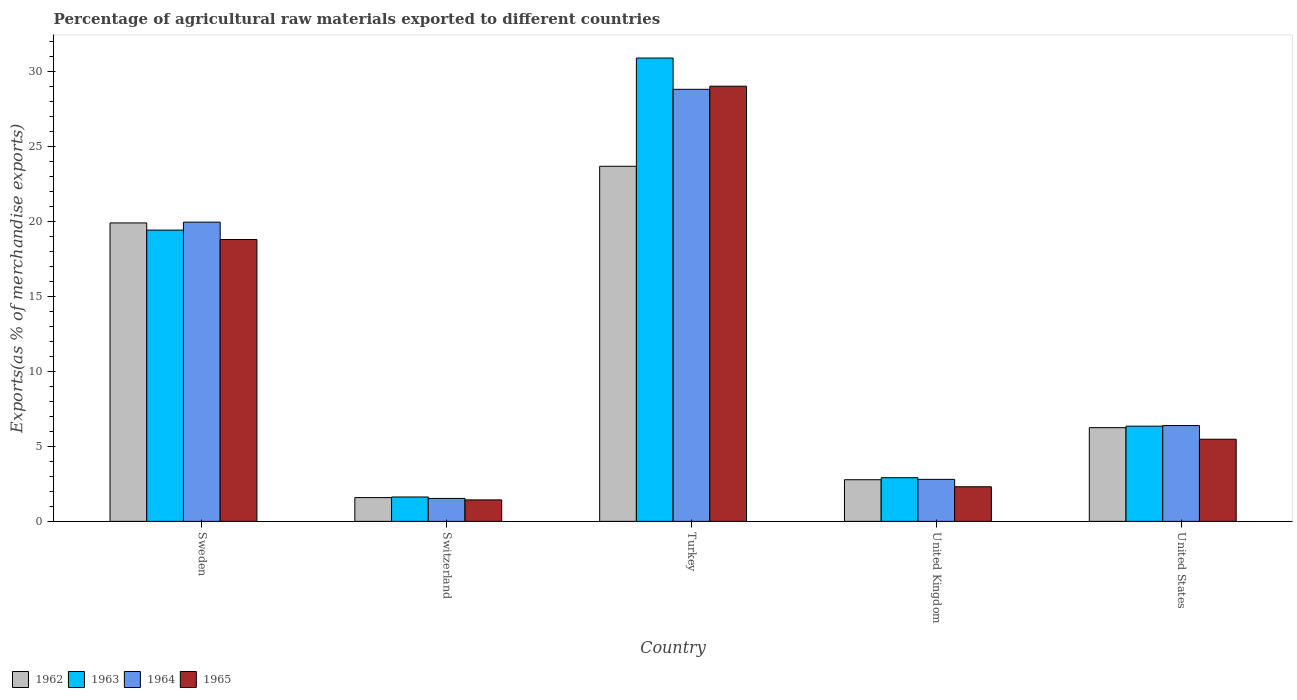How many different coloured bars are there?
Your answer should be very brief. 4. How many bars are there on the 1st tick from the left?
Your answer should be very brief. 4. How many bars are there on the 5th tick from the right?
Ensure brevity in your answer.  4. What is the label of the 2nd group of bars from the left?
Provide a short and direct response. Switzerland. What is the percentage of exports to different countries in 1964 in Turkey?
Keep it short and to the point. 28.78. Across all countries, what is the maximum percentage of exports to different countries in 1963?
Offer a terse response. 30.86. Across all countries, what is the minimum percentage of exports to different countries in 1964?
Make the answer very short. 1.53. In which country was the percentage of exports to different countries in 1965 maximum?
Keep it short and to the point. Turkey. In which country was the percentage of exports to different countries in 1962 minimum?
Keep it short and to the point. Switzerland. What is the total percentage of exports to different countries in 1964 in the graph?
Your response must be concise. 59.42. What is the difference between the percentage of exports to different countries in 1965 in Switzerland and that in United States?
Provide a short and direct response. -4.04. What is the difference between the percentage of exports to different countries in 1964 in United Kingdom and the percentage of exports to different countries in 1962 in Turkey?
Offer a very short reply. -20.86. What is the average percentage of exports to different countries in 1965 per country?
Keep it short and to the point. 11.39. What is the difference between the percentage of exports to different countries of/in 1962 and percentage of exports to different countries of/in 1964 in Switzerland?
Give a very brief answer. 0.06. In how many countries, is the percentage of exports to different countries in 1964 greater than 26 %?
Offer a very short reply. 1. What is the ratio of the percentage of exports to different countries in 1965 in Switzerland to that in United Kingdom?
Make the answer very short. 0.62. What is the difference between the highest and the second highest percentage of exports to different countries in 1963?
Your answer should be compact. -11.46. What is the difference between the highest and the lowest percentage of exports to different countries in 1964?
Your answer should be compact. 27.25. What does the 4th bar from the left in Switzerland represents?
Your answer should be very brief. 1965. What does the 4th bar from the right in Switzerland represents?
Keep it short and to the point. 1962. Is it the case that in every country, the sum of the percentage of exports to different countries in 1965 and percentage of exports to different countries in 1963 is greater than the percentage of exports to different countries in 1964?
Your response must be concise. Yes. How many bars are there?
Your response must be concise. 20. How many countries are there in the graph?
Give a very brief answer. 5. What is the difference between two consecutive major ticks on the Y-axis?
Provide a succinct answer. 5. Does the graph contain any zero values?
Your answer should be very brief. No. Does the graph contain grids?
Provide a succinct answer. No. What is the title of the graph?
Make the answer very short. Percentage of agricultural raw materials exported to different countries. Does "1989" appear as one of the legend labels in the graph?
Offer a very short reply. No. What is the label or title of the Y-axis?
Your response must be concise. Exports(as % of merchandise exports). What is the Exports(as % of merchandise exports) of 1962 in Sweden?
Provide a short and direct response. 19.88. What is the Exports(as % of merchandise exports) of 1963 in Sweden?
Offer a very short reply. 19.4. What is the Exports(as % of merchandise exports) of 1964 in Sweden?
Provide a succinct answer. 19.93. What is the Exports(as % of merchandise exports) of 1965 in Sweden?
Make the answer very short. 18.78. What is the Exports(as % of merchandise exports) in 1962 in Switzerland?
Your answer should be compact. 1.58. What is the Exports(as % of merchandise exports) of 1963 in Switzerland?
Provide a short and direct response. 1.62. What is the Exports(as % of merchandise exports) in 1964 in Switzerland?
Ensure brevity in your answer.  1.53. What is the Exports(as % of merchandise exports) in 1965 in Switzerland?
Offer a very short reply. 1.43. What is the Exports(as % of merchandise exports) in 1962 in Turkey?
Your response must be concise. 23.65. What is the Exports(as % of merchandise exports) in 1963 in Turkey?
Your answer should be compact. 30.86. What is the Exports(as % of merchandise exports) in 1964 in Turkey?
Give a very brief answer. 28.78. What is the Exports(as % of merchandise exports) of 1965 in Turkey?
Keep it short and to the point. 28.99. What is the Exports(as % of merchandise exports) of 1962 in United Kingdom?
Make the answer very short. 2.77. What is the Exports(as % of merchandise exports) of 1963 in United Kingdom?
Your answer should be very brief. 2.91. What is the Exports(as % of merchandise exports) of 1964 in United Kingdom?
Your answer should be very brief. 2.8. What is the Exports(as % of merchandise exports) in 1965 in United Kingdom?
Make the answer very short. 2.3. What is the Exports(as % of merchandise exports) of 1962 in United States?
Provide a short and direct response. 6.24. What is the Exports(as % of merchandise exports) of 1963 in United States?
Provide a short and direct response. 6.34. What is the Exports(as % of merchandise exports) of 1964 in United States?
Keep it short and to the point. 6.38. What is the Exports(as % of merchandise exports) in 1965 in United States?
Offer a terse response. 5.47. Across all countries, what is the maximum Exports(as % of merchandise exports) of 1962?
Provide a succinct answer. 23.65. Across all countries, what is the maximum Exports(as % of merchandise exports) of 1963?
Your answer should be very brief. 30.86. Across all countries, what is the maximum Exports(as % of merchandise exports) of 1964?
Your answer should be very brief. 28.78. Across all countries, what is the maximum Exports(as % of merchandise exports) of 1965?
Your answer should be very brief. 28.99. Across all countries, what is the minimum Exports(as % of merchandise exports) of 1962?
Keep it short and to the point. 1.58. Across all countries, what is the minimum Exports(as % of merchandise exports) of 1963?
Your answer should be compact. 1.62. Across all countries, what is the minimum Exports(as % of merchandise exports) in 1964?
Provide a short and direct response. 1.53. Across all countries, what is the minimum Exports(as % of merchandise exports) of 1965?
Your answer should be compact. 1.43. What is the total Exports(as % of merchandise exports) in 1962 in the graph?
Provide a succinct answer. 54.14. What is the total Exports(as % of merchandise exports) in 1963 in the graph?
Offer a terse response. 61.14. What is the total Exports(as % of merchandise exports) of 1964 in the graph?
Make the answer very short. 59.42. What is the total Exports(as % of merchandise exports) of 1965 in the graph?
Offer a terse response. 56.97. What is the difference between the Exports(as % of merchandise exports) in 1962 in Sweden and that in Switzerland?
Ensure brevity in your answer.  18.3. What is the difference between the Exports(as % of merchandise exports) in 1963 in Sweden and that in Switzerland?
Keep it short and to the point. 17.78. What is the difference between the Exports(as % of merchandise exports) of 1964 in Sweden and that in Switzerland?
Offer a very short reply. 18.4. What is the difference between the Exports(as % of merchandise exports) of 1965 in Sweden and that in Switzerland?
Make the answer very short. 17.35. What is the difference between the Exports(as % of merchandise exports) in 1962 in Sweden and that in Turkey?
Offer a very short reply. -3.77. What is the difference between the Exports(as % of merchandise exports) of 1963 in Sweden and that in Turkey?
Provide a succinct answer. -11.46. What is the difference between the Exports(as % of merchandise exports) of 1964 in Sweden and that in Turkey?
Provide a succinct answer. -8.85. What is the difference between the Exports(as % of merchandise exports) of 1965 in Sweden and that in Turkey?
Provide a succinct answer. -10.21. What is the difference between the Exports(as % of merchandise exports) of 1962 in Sweden and that in United Kingdom?
Make the answer very short. 17.11. What is the difference between the Exports(as % of merchandise exports) of 1963 in Sweden and that in United Kingdom?
Give a very brief answer. 16.49. What is the difference between the Exports(as % of merchandise exports) of 1964 in Sweden and that in United Kingdom?
Provide a succinct answer. 17.13. What is the difference between the Exports(as % of merchandise exports) in 1965 in Sweden and that in United Kingdom?
Ensure brevity in your answer.  16.47. What is the difference between the Exports(as % of merchandise exports) in 1962 in Sweden and that in United States?
Keep it short and to the point. 13.64. What is the difference between the Exports(as % of merchandise exports) of 1963 in Sweden and that in United States?
Your response must be concise. 13.06. What is the difference between the Exports(as % of merchandise exports) in 1964 in Sweden and that in United States?
Ensure brevity in your answer.  13.55. What is the difference between the Exports(as % of merchandise exports) of 1965 in Sweden and that in United States?
Offer a very short reply. 13.3. What is the difference between the Exports(as % of merchandise exports) in 1962 in Switzerland and that in Turkey?
Your response must be concise. -22.07. What is the difference between the Exports(as % of merchandise exports) of 1963 in Switzerland and that in Turkey?
Your answer should be compact. -29.24. What is the difference between the Exports(as % of merchandise exports) in 1964 in Switzerland and that in Turkey?
Provide a short and direct response. -27.25. What is the difference between the Exports(as % of merchandise exports) of 1965 in Switzerland and that in Turkey?
Your response must be concise. -27.56. What is the difference between the Exports(as % of merchandise exports) in 1962 in Switzerland and that in United Kingdom?
Keep it short and to the point. -1.19. What is the difference between the Exports(as % of merchandise exports) of 1963 in Switzerland and that in United Kingdom?
Provide a succinct answer. -1.28. What is the difference between the Exports(as % of merchandise exports) of 1964 in Switzerland and that in United Kingdom?
Offer a terse response. -1.27. What is the difference between the Exports(as % of merchandise exports) in 1965 in Switzerland and that in United Kingdom?
Ensure brevity in your answer.  -0.87. What is the difference between the Exports(as % of merchandise exports) in 1962 in Switzerland and that in United States?
Your response must be concise. -4.66. What is the difference between the Exports(as % of merchandise exports) of 1963 in Switzerland and that in United States?
Your response must be concise. -4.72. What is the difference between the Exports(as % of merchandise exports) in 1964 in Switzerland and that in United States?
Provide a succinct answer. -4.85. What is the difference between the Exports(as % of merchandise exports) in 1965 in Switzerland and that in United States?
Give a very brief answer. -4.04. What is the difference between the Exports(as % of merchandise exports) of 1962 in Turkey and that in United Kingdom?
Ensure brevity in your answer.  20.88. What is the difference between the Exports(as % of merchandise exports) in 1963 in Turkey and that in United Kingdom?
Your response must be concise. 27.96. What is the difference between the Exports(as % of merchandise exports) in 1964 in Turkey and that in United Kingdom?
Your response must be concise. 25.98. What is the difference between the Exports(as % of merchandise exports) of 1965 in Turkey and that in United Kingdom?
Ensure brevity in your answer.  26.68. What is the difference between the Exports(as % of merchandise exports) in 1962 in Turkey and that in United States?
Keep it short and to the point. 17.41. What is the difference between the Exports(as % of merchandise exports) of 1963 in Turkey and that in United States?
Offer a terse response. 24.52. What is the difference between the Exports(as % of merchandise exports) in 1964 in Turkey and that in United States?
Your response must be concise. 22.4. What is the difference between the Exports(as % of merchandise exports) in 1965 in Turkey and that in United States?
Your answer should be very brief. 23.52. What is the difference between the Exports(as % of merchandise exports) in 1962 in United Kingdom and that in United States?
Your answer should be compact. -3.47. What is the difference between the Exports(as % of merchandise exports) of 1963 in United Kingdom and that in United States?
Offer a very short reply. -3.43. What is the difference between the Exports(as % of merchandise exports) in 1964 in United Kingdom and that in United States?
Offer a terse response. -3.58. What is the difference between the Exports(as % of merchandise exports) of 1965 in United Kingdom and that in United States?
Provide a succinct answer. -3.17. What is the difference between the Exports(as % of merchandise exports) in 1962 in Sweden and the Exports(as % of merchandise exports) in 1963 in Switzerland?
Provide a succinct answer. 18.26. What is the difference between the Exports(as % of merchandise exports) in 1962 in Sweden and the Exports(as % of merchandise exports) in 1964 in Switzerland?
Your answer should be very brief. 18.35. What is the difference between the Exports(as % of merchandise exports) of 1962 in Sweden and the Exports(as % of merchandise exports) of 1965 in Switzerland?
Your answer should be compact. 18.45. What is the difference between the Exports(as % of merchandise exports) in 1963 in Sweden and the Exports(as % of merchandise exports) in 1964 in Switzerland?
Offer a very short reply. 17.87. What is the difference between the Exports(as % of merchandise exports) of 1963 in Sweden and the Exports(as % of merchandise exports) of 1965 in Switzerland?
Offer a terse response. 17.97. What is the difference between the Exports(as % of merchandise exports) of 1964 in Sweden and the Exports(as % of merchandise exports) of 1965 in Switzerland?
Your response must be concise. 18.5. What is the difference between the Exports(as % of merchandise exports) of 1962 in Sweden and the Exports(as % of merchandise exports) of 1963 in Turkey?
Offer a terse response. -10.98. What is the difference between the Exports(as % of merchandise exports) in 1962 in Sweden and the Exports(as % of merchandise exports) in 1964 in Turkey?
Give a very brief answer. -8.9. What is the difference between the Exports(as % of merchandise exports) of 1962 in Sweden and the Exports(as % of merchandise exports) of 1965 in Turkey?
Your answer should be very brief. -9.11. What is the difference between the Exports(as % of merchandise exports) in 1963 in Sweden and the Exports(as % of merchandise exports) in 1964 in Turkey?
Make the answer very short. -9.38. What is the difference between the Exports(as % of merchandise exports) in 1963 in Sweden and the Exports(as % of merchandise exports) in 1965 in Turkey?
Offer a terse response. -9.59. What is the difference between the Exports(as % of merchandise exports) in 1964 in Sweden and the Exports(as % of merchandise exports) in 1965 in Turkey?
Offer a very short reply. -9.06. What is the difference between the Exports(as % of merchandise exports) in 1962 in Sweden and the Exports(as % of merchandise exports) in 1963 in United Kingdom?
Offer a terse response. 16.97. What is the difference between the Exports(as % of merchandise exports) of 1962 in Sweden and the Exports(as % of merchandise exports) of 1964 in United Kingdom?
Provide a short and direct response. 17.08. What is the difference between the Exports(as % of merchandise exports) of 1962 in Sweden and the Exports(as % of merchandise exports) of 1965 in United Kingdom?
Provide a short and direct response. 17.58. What is the difference between the Exports(as % of merchandise exports) in 1963 in Sweden and the Exports(as % of merchandise exports) in 1964 in United Kingdom?
Provide a short and direct response. 16.6. What is the difference between the Exports(as % of merchandise exports) in 1963 in Sweden and the Exports(as % of merchandise exports) in 1965 in United Kingdom?
Make the answer very short. 17.1. What is the difference between the Exports(as % of merchandise exports) of 1964 in Sweden and the Exports(as % of merchandise exports) of 1965 in United Kingdom?
Your response must be concise. 17.63. What is the difference between the Exports(as % of merchandise exports) of 1962 in Sweden and the Exports(as % of merchandise exports) of 1963 in United States?
Give a very brief answer. 13.54. What is the difference between the Exports(as % of merchandise exports) in 1962 in Sweden and the Exports(as % of merchandise exports) in 1964 in United States?
Provide a short and direct response. 13.5. What is the difference between the Exports(as % of merchandise exports) of 1962 in Sweden and the Exports(as % of merchandise exports) of 1965 in United States?
Provide a succinct answer. 14.41. What is the difference between the Exports(as % of merchandise exports) in 1963 in Sweden and the Exports(as % of merchandise exports) in 1964 in United States?
Provide a succinct answer. 13.02. What is the difference between the Exports(as % of merchandise exports) in 1963 in Sweden and the Exports(as % of merchandise exports) in 1965 in United States?
Your answer should be very brief. 13.93. What is the difference between the Exports(as % of merchandise exports) of 1964 in Sweden and the Exports(as % of merchandise exports) of 1965 in United States?
Provide a succinct answer. 14.46. What is the difference between the Exports(as % of merchandise exports) of 1962 in Switzerland and the Exports(as % of merchandise exports) of 1963 in Turkey?
Provide a succinct answer. -29.28. What is the difference between the Exports(as % of merchandise exports) of 1962 in Switzerland and the Exports(as % of merchandise exports) of 1964 in Turkey?
Your answer should be compact. -27.2. What is the difference between the Exports(as % of merchandise exports) of 1962 in Switzerland and the Exports(as % of merchandise exports) of 1965 in Turkey?
Your answer should be very brief. -27.4. What is the difference between the Exports(as % of merchandise exports) of 1963 in Switzerland and the Exports(as % of merchandise exports) of 1964 in Turkey?
Ensure brevity in your answer.  -27.16. What is the difference between the Exports(as % of merchandise exports) of 1963 in Switzerland and the Exports(as % of merchandise exports) of 1965 in Turkey?
Keep it short and to the point. -27.36. What is the difference between the Exports(as % of merchandise exports) of 1964 in Switzerland and the Exports(as % of merchandise exports) of 1965 in Turkey?
Your response must be concise. -27.46. What is the difference between the Exports(as % of merchandise exports) of 1962 in Switzerland and the Exports(as % of merchandise exports) of 1963 in United Kingdom?
Offer a very short reply. -1.32. What is the difference between the Exports(as % of merchandise exports) of 1962 in Switzerland and the Exports(as % of merchandise exports) of 1964 in United Kingdom?
Give a very brief answer. -1.21. What is the difference between the Exports(as % of merchandise exports) in 1962 in Switzerland and the Exports(as % of merchandise exports) in 1965 in United Kingdom?
Your answer should be very brief. -0.72. What is the difference between the Exports(as % of merchandise exports) of 1963 in Switzerland and the Exports(as % of merchandise exports) of 1964 in United Kingdom?
Keep it short and to the point. -1.17. What is the difference between the Exports(as % of merchandise exports) in 1963 in Switzerland and the Exports(as % of merchandise exports) in 1965 in United Kingdom?
Your response must be concise. -0.68. What is the difference between the Exports(as % of merchandise exports) in 1964 in Switzerland and the Exports(as % of merchandise exports) in 1965 in United Kingdom?
Ensure brevity in your answer.  -0.78. What is the difference between the Exports(as % of merchandise exports) of 1962 in Switzerland and the Exports(as % of merchandise exports) of 1963 in United States?
Offer a very short reply. -4.76. What is the difference between the Exports(as % of merchandise exports) of 1962 in Switzerland and the Exports(as % of merchandise exports) of 1964 in United States?
Keep it short and to the point. -4.8. What is the difference between the Exports(as % of merchandise exports) of 1962 in Switzerland and the Exports(as % of merchandise exports) of 1965 in United States?
Your answer should be compact. -3.89. What is the difference between the Exports(as % of merchandise exports) of 1963 in Switzerland and the Exports(as % of merchandise exports) of 1964 in United States?
Offer a very short reply. -4.76. What is the difference between the Exports(as % of merchandise exports) of 1963 in Switzerland and the Exports(as % of merchandise exports) of 1965 in United States?
Offer a very short reply. -3.85. What is the difference between the Exports(as % of merchandise exports) of 1964 in Switzerland and the Exports(as % of merchandise exports) of 1965 in United States?
Your answer should be compact. -3.94. What is the difference between the Exports(as % of merchandise exports) of 1962 in Turkey and the Exports(as % of merchandise exports) of 1963 in United Kingdom?
Provide a short and direct response. 20.75. What is the difference between the Exports(as % of merchandise exports) of 1962 in Turkey and the Exports(as % of merchandise exports) of 1964 in United Kingdom?
Offer a very short reply. 20.86. What is the difference between the Exports(as % of merchandise exports) of 1962 in Turkey and the Exports(as % of merchandise exports) of 1965 in United Kingdom?
Provide a short and direct response. 21.35. What is the difference between the Exports(as % of merchandise exports) of 1963 in Turkey and the Exports(as % of merchandise exports) of 1964 in United Kingdom?
Offer a very short reply. 28.07. What is the difference between the Exports(as % of merchandise exports) in 1963 in Turkey and the Exports(as % of merchandise exports) in 1965 in United Kingdom?
Make the answer very short. 28.56. What is the difference between the Exports(as % of merchandise exports) of 1964 in Turkey and the Exports(as % of merchandise exports) of 1965 in United Kingdom?
Offer a terse response. 26.48. What is the difference between the Exports(as % of merchandise exports) in 1962 in Turkey and the Exports(as % of merchandise exports) in 1963 in United States?
Give a very brief answer. 17.31. What is the difference between the Exports(as % of merchandise exports) in 1962 in Turkey and the Exports(as % of merchandise exports) in 1964 in United States?
Offer a terse response. 17.27. What is the difference between the Exports(as % of merchandise exports) of 1962 in Turkey and the Exports(as % of merchandise exports) of 1965 in United States?
Your answer should be compact. 18.18. What is the difference between the Exports(as % of merchandise exports) of 1963 in Turkey and the Exports(as % of merchandise exports) of 1964 in United States?
Your answer should be very brief. 24.48. What is the difference between the Exports(as % of merchandise exports) in 1963 in Turkey and the Exports(as % of merchandise exports) in 1965 in United States?
Provide a short and direct response. 25.39. What is the difference between the Exports(as % of merchandise exports) of 1964 in Turkey and the Exports(as % of merchandise exports) of 1965 in United States?
Your response must be concise. 23.31. What is the difference between the Exports(as % of merchandise exports) of 1962 in United Kingdom and the Exports(as % of merchandise exports) of 1963 in United States?
Make the answer very short. -3.57. What is the difference between the Exports(as % of merchandise exports) in 1962 in United Kingdom and the Exports(as % of merchandise exports) in 1964 in United States?
Your answer should be very brief. -3.61. What is the difference between the Exports(as % of merchandise exports) in 1962 in United Kingdom and the Exports(as % of merchandise exports) in 1965 in United States?
Your answer should be very brief. -2.7. What is the difference between the Exports(as % of merchandise exports) in 1963 in United Kingdom and the Exports(as % of merchandise exports) in 1964 in United States?
Ensure brevity in your answer.  -3.47. What is the difference between the Exports(as % of merchandise exports) of 1963 in United Kingdom and the Exports(as % of merchandise exports) of 1965 in United States?
Keep it short and to the point. -2.56. What is the difference between the Exports(as % of merchandise exports) of 1964 in United Kingdom and the Exports(as % of merchandise exports) of 1965 in United States?
Your answer should be compact. -2.67. What is the average Exports(as % of merchandise exports) of 1962 per country?
Make the answer very short. 10.83. What is the average Exports(as % of merchandise exports) in 1963 per country?
Make the answer very short. 12.23. What is the average Exports(as % of merchandise exports) of 1964 per country?
Keep it short and to the point. 11.88. What is the average Exports(as % of merchandise exports) in 1965 per country?
Provide a succinct answer. 11.39. What is the difference between the Exports(as % of merchandise exports) of 1962 and Exports(as % of merchandise exports) of 1963 in Sweden?
Provide a short and direct response. 0.48. What is the difference between the Exports(as % of merchandise exports) in 1962 and Exports(as % of merchandise exports) in 1964 in Sweden?
Provide a short and direct response. -0.05. What is the difference between the Exports(as % of merchandise exports) in 1962 and Exports(as % of merchandise exports) in 1965 in Sweden?
Offer a very short reply. 1.1. What is the difference between the Exports(as % of merchandise exports) in 1963 and Exports(as % of merchandise exports) in 1964 in Sweden?
Your response must be concise. -0.53. What is the difference between the Exports(as % of merchandise exports) of 1963 and Exports(as % of merchandise exports) of 1965 in Sweden?
Offer a very short reply. 0.63. What is the difference between the Exports(as % of merchandise exports) of 1964 and Exports(as % of merchandise exports) of 1965 in Sweden?
Keep it short and to the point. 1.16. What is the difference between the Exports(as % of merchandise exports) of 1962 and Exports(as % of merchandise exports) of 1963 in Switzerland?
Give a very brief answer. -0.04. What is the difference between the Exports(as % of merchandise exports) in 1962 and Exports(as % of merchandise exports) in 1964 in Switzerland?
Your answer should be compact. 0.06. What is the difference between the Exports(as % of merchandise exports) in 1962 and Exports(as % of merchandise exports) in 1965 in Switzerland?
Offer a very short reply. 0.15. What is the difference between the Exports(as % of merchandise exports) of 1963 and Exports(as % of merchandise exports) of 1964 in Switzerland?
Give a very brief answer. 0.1. What is the difference between the Exports(as % of merchandise exports) of 1963 and Exports(as % of merchandise exports) of 1965 in Switzerland?
Offer a terse response. 0.19. What is the difference between the Exports(as % of merchandise exports) in 1964 and Exports(as % of merchandise exports) in 1965 in Switzerland?
Provide a short and direct response. 0.1. What is the difference between the Exports(as % of merchandise exports) of 1962 and Exports(as % of merchandise exports) of 1963 in Turkey?
Give a very brief answer. -7.21. What is the difference between the Exports(as % of merchandise exports) of 1962 and Exports(as % of merchandise exports) of 1964 in Turkey?
Your response must be concise. -5.13. What is the difference between the Exports(as % of merchandise exports) in 1962 and Exports(as % of merchandise exports) in 1965 in Turkey?
Give a very brief answer. -5.33. What is the difference between the Exports(as % of merchandise exports) of 1963 and Exports(as % of merchandise exports) of 1964 in Turkey?
Your response must be concise. 2.08. What is the difference between the Exports(as % of merchandise exports) in 1963 and Exports(as % of merchandise exports) in 1965 in Turkey?
Your answer should be very brief. 1.88. What is the difference between the Exports(as % of merchandise exports) of 1964 and Exports(as % of merchandise exports) of 1965 in Turkey?
Give a very brief answer. -0.21. What is the difference between the Exports(as % of merchandise exports) of 1962 and Exports(as % of merchandise exports) of 1963 in United Kingdom?
Offer a terse response. -0.13. What is the difference between the Exports(as % of merchandise exports) of 1962 and Exports(as % of merchandise exports) of 1964 in United Kingdom?
Your response must be concise. -0.02. What is the difference between the Exports(as % of merchandise exports) in 1962 and Exports(as % of merchandise exports) in 1965 in United Kingdom?
Keep it short and to the point. 0.47. What is the difference between the Exports(as % of merchandise exports) in 1963 and Exports(as % of merchandise exports) in 1964 in United Kingdom?
Provide a succinct answer. 0.11. What is the difference between the Exports(as % of merchandise exports) in 1963 and Exports(as % of merchandise exports) in 1965 in United Kingdom?
Offer a terse response. 0.6. What is the difference between the Exports(as % of merchandise exports) of 1964 and Exports(as % of merchandise exports) of 1965 in United Kingdom?
Your answer should be compact. 0.49. What is the difference between the Exports(as % of merchandise exports) in 1962 and Exports(as % of merchandise exports) in 1963 in United States?
Make the answer very short. -0.1. What is the difference between the Exports(as % of merchandise exports) in 1962 and Exports(as % of merchandise exports) in 1964 in United States?
Provide a succinct answer. -0.14. What is the difference between the Exports(as % of merchandise exports) in 1962 and Exports(as % of merchandise exports) in 1965 in United States?
Your answer should be very brief. 0.77. What is the difference between the Exports(as % of merchandise exports) in 1963 and Exports(as % of merchandise exports) in 1964 in United States?
Your answer should be very brief. -0.04. What is the difference between the Exports(as % of merchandise exports) of 1963 and Exports(as % of merchandise exports) of 1965 in United States?
Your answer should be very brief. 0.87. What is the difference between the Exports(as % of merchandise exports) of 1964 and Exports(as % of merchandise exports) of 1965 in United States?
Your answer should be compact. 0.91. What is the ratio of the Exports(as % of merchandise exports) in 1962 in Sweden to that in Switzerland?
Your answer should be compact. 12.55. What is the ratio of the Exports(as % of merchandise exports) in 1963 in Sweden to that in Switzerland?
Keep it short and to the point. 11.95. What is the ratio of the Exports(as % of merchandise exports) in 1964 in Sweden to that in Switzerland?
Provide a short and direct response. 13.04. What is the ratio of the Exports(as % of merchandise exports) in 1965 in Sweden to that in Switzerland?
Your response must be concise. 13.13. What is the ratio of the Exports(as % of merchandise exports) in 1962 in Sweden to that in Turkey?
Keep it short and to the point. 0.84. What is the ratio of the Exports(as % of merchandise exports) of 1963 in Sweden to that in Turkey?
Offer a terse response. 0.63. What is the ratio of the Exports(as % of merchandise exports) of 1964 in Sweden to that in Turkey?
Offer a terse response. 0.69. What is the ratio of the Exports(as % of merchandise exports) in 1965 in Sweden to that in Turkey?
Give a very brief answer. 0.65. What is the ratio of the Exports(as % of merchandise exports) in 1962 in Sweden to that in United Kingdom?
Your answer should be compact. 7.17. What is the ratio of the Exports(as % of merchandise exports) in 1963 in Sweden to that in United Kingdom?
Give a very brief answer. 6.67. What is the ratio of the Exports(as % of merchandise exports) of 1964 in Sweden to that in United Kingdom?
Ensure brevity in your answer.  7.12. What is the ratio of the Exports(as % of merchandise exports) of 1965 in Sweden to that in United Kingdom?
Keep it short and to the point. 8.15. What is the ratio of the Exports(as % of merchandise exports) in 1962 in Sweden to that in United States?
Your answer should be compact. 3.18. What is the ratio of the Exports(as % of merchandise exports) of 1963 in Sweden to that in United States?
Keep it short and to the point. 3.06. What is the ratio of the Exports(as % of merchandise exports) of 1964 in Sweden to that in United States?
Make the answer very short. 3.12. What is the ratio of the Exports(as % of merchandise exports) of 1965 in Sweden to that in United States?
Your answer should be very brief. 3.43. What is the ratio of the Exports(as % of merchandise exports) of 1962 in Switzerland to that in Turkey?
Offer a very short reply. 0.07. What is the ratio of the Exports(as % of merchandise exports) in 1963 in Switzerland to that in Turkey?
Ensure brevity in your answer.  0.05. What is the ratio of the Exports(as % of merchandise exports) in 1964 in Switzerland to that in Turkey?
Your answer should be very brief. 0.05. What is the ratio of the Exports(as % of merchandise exports) of 1965 in Switzerland to that in Turkey?
Offer a very short reply. 0.05. What is the ratio of the Exports(as % of merchandise exports) in 1962 in Switzerland to that in United Kingdom?
Offer a terse response. 0.57. What is the ratio of the Exports(as % of merchandise exports) of 1963 in Switzerland to that in United Kingdom?
Offer a very short reply. 0.56. What is the ratio of the Exports(as % of merchandise exports) of 1964 in Switzerland to that in United Kingdom?
Offer a very short reply. 0.55. What is the ratio of the Exports(as % of merchandise exports) in 1965 in Switzerland to that in United Kingdom?
Provide a succinct answer. 0.62. What is the ratio of the Exports(as % of merchandise exports) of 1962 in Switzerland to that in United States?
Your answer should be compact. 0.25. What is the ratio of the Exports(as % of merchandise exports) in 1963 in Switzerland to that in United States?
Offer a very short reply. 0.26. What is the ratio of the Exports(as % of merchandise exports) of 1964 in Switzerland to that in United States?
Offer a terse response. 0.24. What is the ratio of the Exports(as % of merchandise exports) of 1965 in Switzerland to that in United States?
Offer a terse response. 0.26. What is the ratio of the Exports(as % of merchandise exports) in 1962 in Turkey to that in United Kingdom?
Your answer should be compact. 8.53. What is the ratio of the Exports(as % of merchandise exports) of 1963 in Turkey to that in United Kingdom?
Keep it short and to the point. 10.61. What is the ratio of the Exports(as % of merchandise exports) of 1964 in Turkey to that in United Kingdom?
Ensure brevity in your answer.  10.28. What is the ratio of the Exports(as % of merchandise exports) in 1965 in Turkey to that in United Kingdom?
Make the answer very short. 12.58. What is the ratio of the Exports(as % of merchandise exports) in 1962 in Turkey to that in United States?
Provide a short and direct response. 3.79. What is the ratio of the Exports(as % of merchandise exports) in 1963 in Turkey to that in United States?
Make the answer very short. 4.87. What is the ratio of the Exports(as % of merchandise exports) of 1964 in Turkey to that in United States?
Give a very brief answer. 4.51. What is the ratio of the Exports(as % of merchandise exports) in 1965 in Turkey to that in United States?
Your answer should be compact. 5.3. What is the ratio of the Exports(as % of merchandise exports) in 1962 in United Kingdom to that in United States?
Give a very brief answer. 0.44. What is the ratio of the Exports(as % of merchandise exports) of 1963 in United Kingdom to that in United States?
Your answer should be very brief. 0.46. What is the ratio of the Exports(as % of merchandise exports) in 1964 in United Kingdom to that in United States?
Give a very brief answer. 0.44. What is the ratio of the Exports(as % of merchandise exports) in 1965 in United Kingdom to that in United States?
Provide a succinct answer. 0.42. What is the difference between the highest and the second highest Exports(as % of merchandise exports) in 1962?
Offer a terse response. 3.77. What is the difference between the highest and the second highest Exports(as % of merchandise exports) of 1963?
Keep it short and to the point. 11.46. What is the difference between the highest and the second highest Exports(as % of merchandise exports) of 1964?
Make the answer very short. 8.85. What is the difference between the highest and the second highest Exports(as % of merchandise exports) of 1965?
Offer a terse response. 10.21. What is the difference between the highest and the lowest Exports(as % of merchandise exports) of 1962?
Ensure brevity in your answer.  22.07. What is the difference between the highest and the lowest Exports(as % of merchandise exports) in 1963?
Provide a succinct answer. 29.24. What is the difference between the highest and the lowest Exports(as % of merchandise exports) of 1964?
Your answer should be compact. 27.25. What is the difference between the highest and the lowest Exports(as % of merchandise exports) of 1965?
Give a very brief answer. 27.56. 